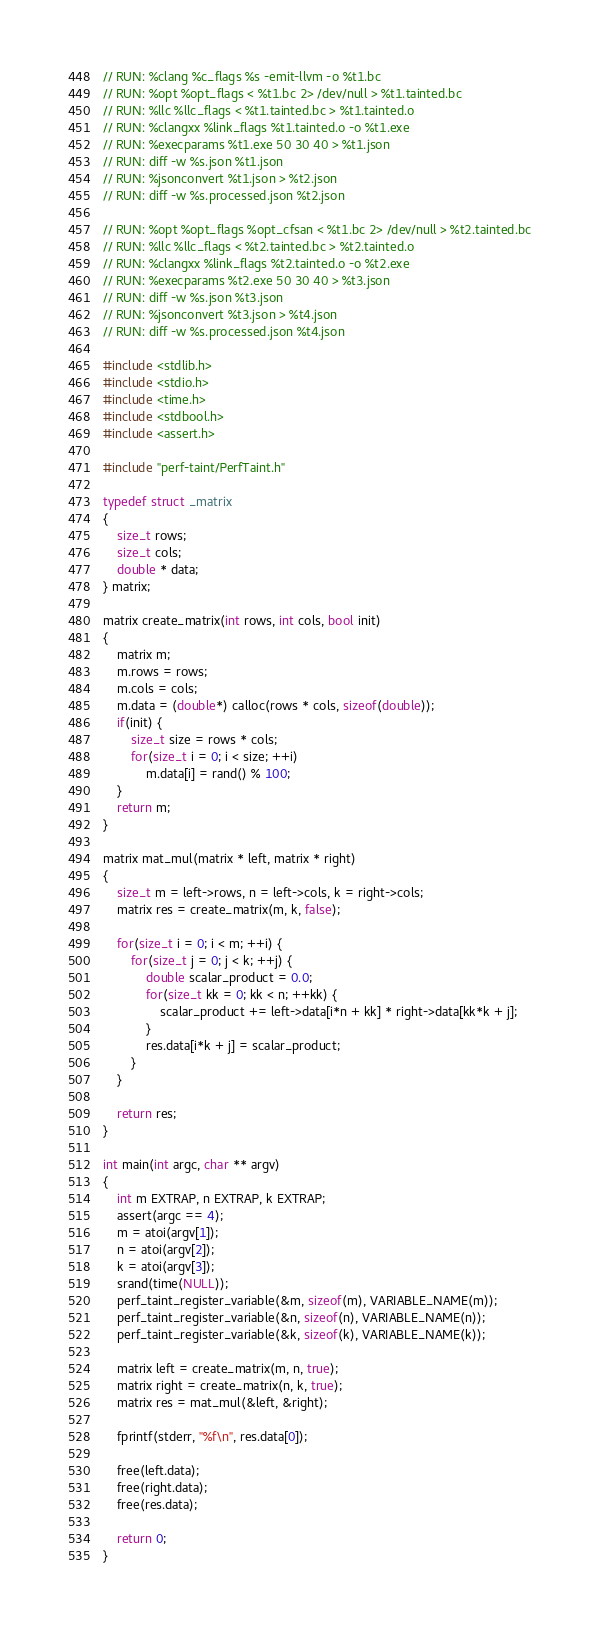<code> <loc_0><loc_0><loc_500><loc_500><_C_>// RUN: %clang %c_flags %s -emit-llvm -o %t1.bc
// RUN: %opt %opt_flags < %t1.bc 2> /dev/null > %t1.tainted.bc
// RUN: %llc %llc_flags < %t1.tainted.bc > %t1.tainted.o
// RUN: %clangxx %link_flags %t1.tainted.o -o %t1.exe
// RUN: %execparams %t1.exe 50 30 40 > %t1.json
// RUN: diff -w %s.json %t1.json
// RUN: %jsonconvert %t1.json > %t2.json
// RUN: diff -w %s.processed.json %t2.json

// RUN: %opt %opt_flags %opt_cfsan < %t1.bc 2> /dev/null > %t2.tainted.bc
// RUN: %llc %llc_flags < %t2.tainted.bc > %t2.tainted.o
// RUN: %clangxx %link_flags %t2.tainted.o -o %t2.exe
// RUN: %execparams %t2.exe 50 30 40 > %t3.json
// RUN: diff -w %s.json %t3.json
// RUN: %jsonconvert %t3.json > %t4.json
// RUN: diff -w %s.processed.json %t4.json

#include <stdlib.h>
#include <stdio.h>
#include <time.h>
#include <stdbool.h>
#include <assert.h>

#include "perf-taint/PerfTaint.h"

typedef struct _matrix
{
    size_t rows;
    size_t cols;
    double * data;
} matrix;

matrix create_matrix(int rows, int cols, bool init)
{
    matrix m;
    m.rows = rows;
    m.cols = cols;
    m.data = (double*) calloc(rows * cols, sizeof(double));
    if(init) {
        size_t size = rows * cols;
        for(size_t i = 0; i < size; ++i)
            m.data[i] = rand() % 100;
    }
    return m;
}

matrix mat_mul(matrix * left, matrix * right)
{
    size_t m = left->rows, n = left->cols, k = right->cols;
    matrix res = create_matrix(m, k, false);

    for(size_t i = 0; i < m; ++i) {
        for(size_t j = 0; j < k; ++j) {
            double scalar_product = 0.0;
            for(size_t kk = 0; kk < n; ++kk) {
                scalar_product += left->data[i*n + kk] * right->data[kk*k + j];
            }
            res.data[i*k + j] = scalar_product;
        }
    }

    return res;
}

int main(int argc, char ** argv)
{
    int m EXTRAP, n EXTRAP, k EXTRAP;
    assert(argc == 4);
    m = atoi(argv[1]);
    n = atoi(argv[2]);
    k = atoi(argv[3]);
    srand(time(NULL));
    perf_taint_register_variable(&m, sizeof(m), VARIABLE_NAME(m));
    perf_taint_register_variable(&n, sizeof(n), VARIABLE_NAME(n));
    perf_taint_register_variable(&k, sizeof(k), VARIABLE_NAME(k));

    matrix left = create_matrix(m, n, true);
    matrix right = create_matrix(n, k, true);
    matrix res = mat_mul(&left, &right);

    fprintf(stderr, "%f\n", res.data[0]);

    free(left.data);
    free(right.data);
    free(res.data);

    return 0;
}
</code> 